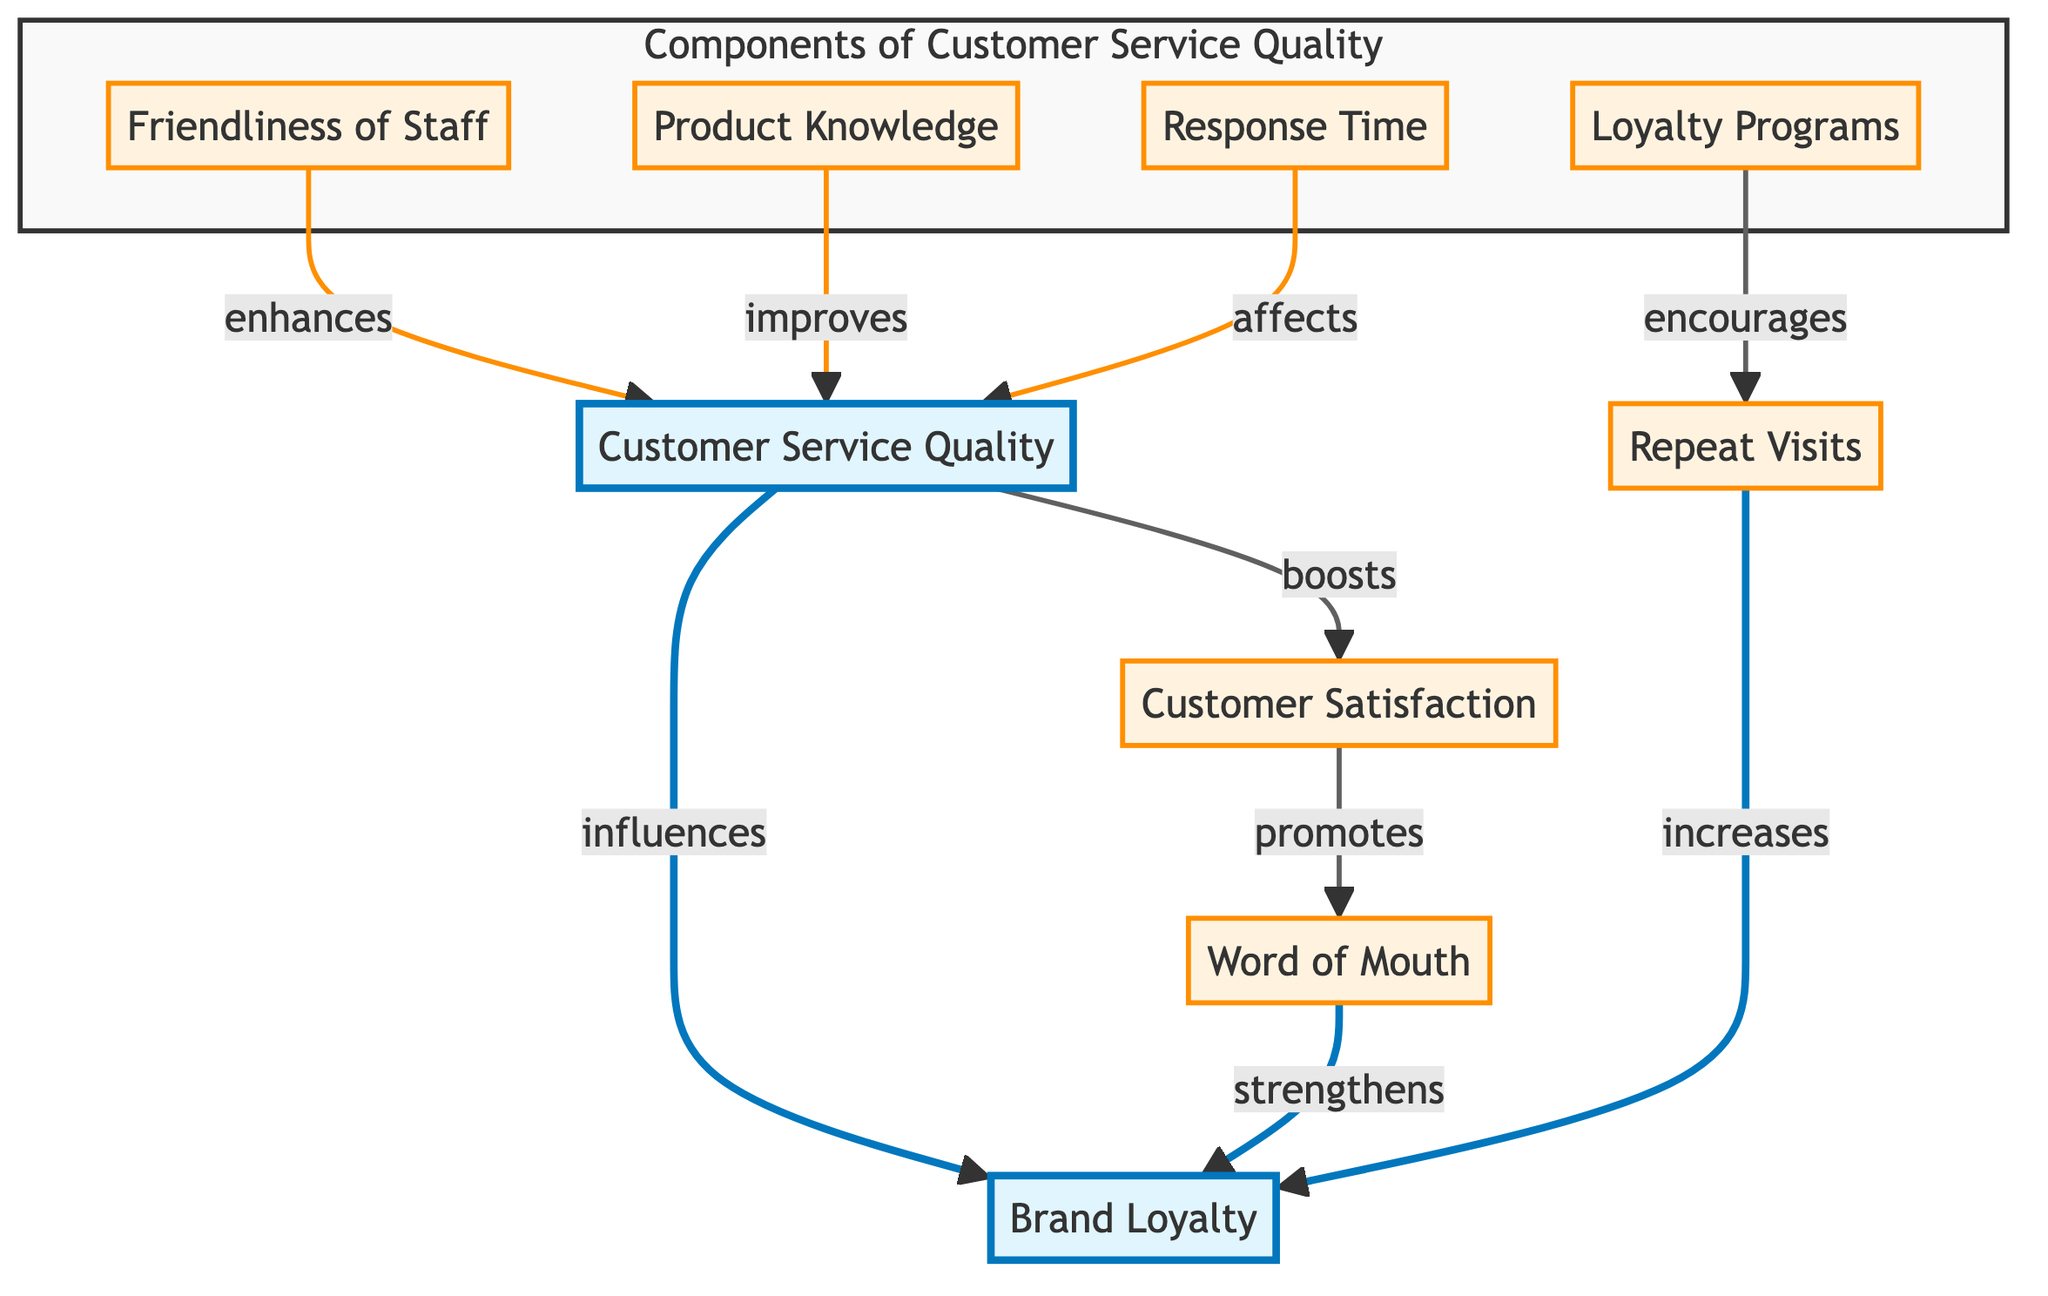What is the primary factor influencing brand loyalty? The diagram shows a direct arrow from "Customer Service Quality" to "Brand Loyalty," indicating that it is the primary influencing factor.
Answer: Customer Service Quality How many components are there in the "Components of Customer Service Quality" subgraph? The subgraph contains four elements: friendliness of staff, product knowledge, response time, and loyalty programs. Therefore, the total number of components is four.
Answer: Four What role does product knowledge play in the customer service quality? The arrow connecting "Product Knowledge" to "Customer Service Quality" indicates that product knowledge improves customer service quality.
Answer: Improves Which component enhances customer service quality according to the diagram? The diagram shows that "Friendliness of Staff" connects to "Customer Service Quality" and is described as enhancing it.
Answer: Enhances How does customer satisfaction relate to brand loyalty? The diagram indicates that customer satisfaction boosts word of mouth, which in turn strengthens brand loyalty, showing a sequential relationship.
Answer: Strengthens What are the two outcomes mentioned that increase brand loyalty apart from customer service quality? The outcomes that increase brand loyalty as depicted in the diagram are repeat visits and word of mouth, both stemming from customer satisfaction and loyalty programs.
Answer: Repeat Visits, Word of Mouth What effect does response time have on customer service quality? The flowchart directly connects response time to customer service quality with an arrow indicating that it affects it.
Answer: Affects What does the arrow from customer satisfaction to word of mouth signify? The arrow illustrates that customer satisfaction promotes word of mouth, indicating a positive relationship between the two factors.
Answer: Promotes 